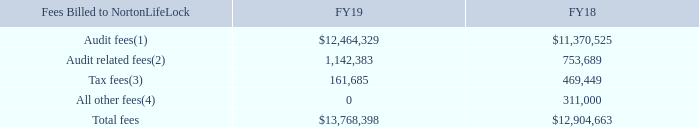Principal Accountant Fees and Services
We regularly review the services and fees from our independent registered public accounting firm, KPMG. These services and fees are also reviewed with the Audit Committee annually. In accordance with standard policy, KPMG periodically rotates the individuals who are responsible for our audit. Our Audit Committee has determined that the providing of certain non-audit services, as described below, is compatible with maintaining the independence of KPMG.
In addition to performing the audit of our consolidated financial statements, KPMG provided various other services during fiscal years 2019 and 2018. Our Audit Committee has determined that KPMG’s provisioning of these services, which are described below, does not impair KPMG’s independence from NortonLifeLock. The aggregate fees billed for fiscal years 2019 and 2018 for each of the following categories of services are as follows:
The categories in the above table have the definitions assigned under Item 9 of Schedule 14A promulgated under the Exchange Act, and these categories include in particular the following components:
(1) ‘‘Audit fees’’ include fees for audit services principally related to the year-end examination and the quarterly reviews of our consolidated financial statements, consultation on matters that arise during a review or audit, review of SEC filings, audit services performed in connection with our acquisitions and divestitures and statutory audit fees.
(2) ‘‘Audit related fees’’ include fees which are for assurance and related services other than those included in Audit fees.
(3) ‘‘Tax fees’’ include fees for tax compliance and advice.
(4) ‘‘All other fees’’ include fees for all other non-audit services, principally for services in relation to certain information technology audits.
An accounting firm other than KPMG performs supplemental internal audit services for NortonLifeLock. Another accounting firm provides the majority of NortonLifeLock’s outside tax services..
What is the public accounting firm that the company engages? Kpmg. What fiscal years are in the table? Fy19, fy18. What does Tax fees include? Fees for tax compliance and advice. What is the average total fees for FY18 and FY19? (13,768,398+12,904,663)/2
Answer: 13336530.5. What is the difference in total fees for FY19 comapred to FY18? 13,768,398-12,904,663
Answer: 863735. What is the percentage increase in Audit related fees from FY18 to FY19?
Answer scale should be: percent. (1,142,383-753,689)/753,689
Answer: 51.57. 